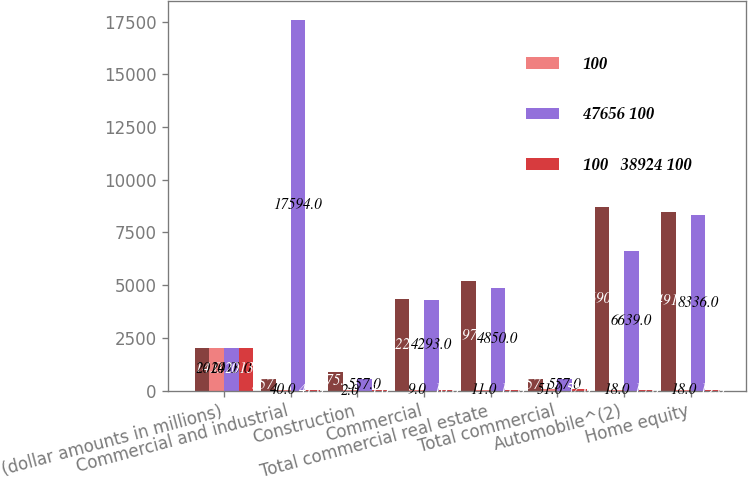<chart> <loc_0><loc_0><loc_500><loc_500><stacked_bar_chart><ecel><fcel>(dollar amounts in millions)<fcel>Commercial and industrial<fcel>Construction<fcel>Commercial<fcel>Total commercial real estate<fcel>Total commercial<fcel>Automobile^(2)<fcel>Home equity<nl><fcel>nan<fcel>2014<fcel>557<fcel>875<fcel>4322<fcel>5197<fcel>557<fcel>8690<fcel>8491<nl><fcel>100<fcel>2014<fcel>40<fcel>2<fcel>9<fcel>11<fcel>51<fcel>18<fcel>18<nl><fcel>47656 100<fcel>2013<fcel>17594<fcel>557<fcel>4293<fcel>4850<fcel>557<fcel>6639<fcel>8336<nl><fcel>100   38924 100<fcel>2013<fcel>41<fcel>1<fcel>10<fcel>11<fcel>52<fcel>15<fcel>19<nl></chart> 